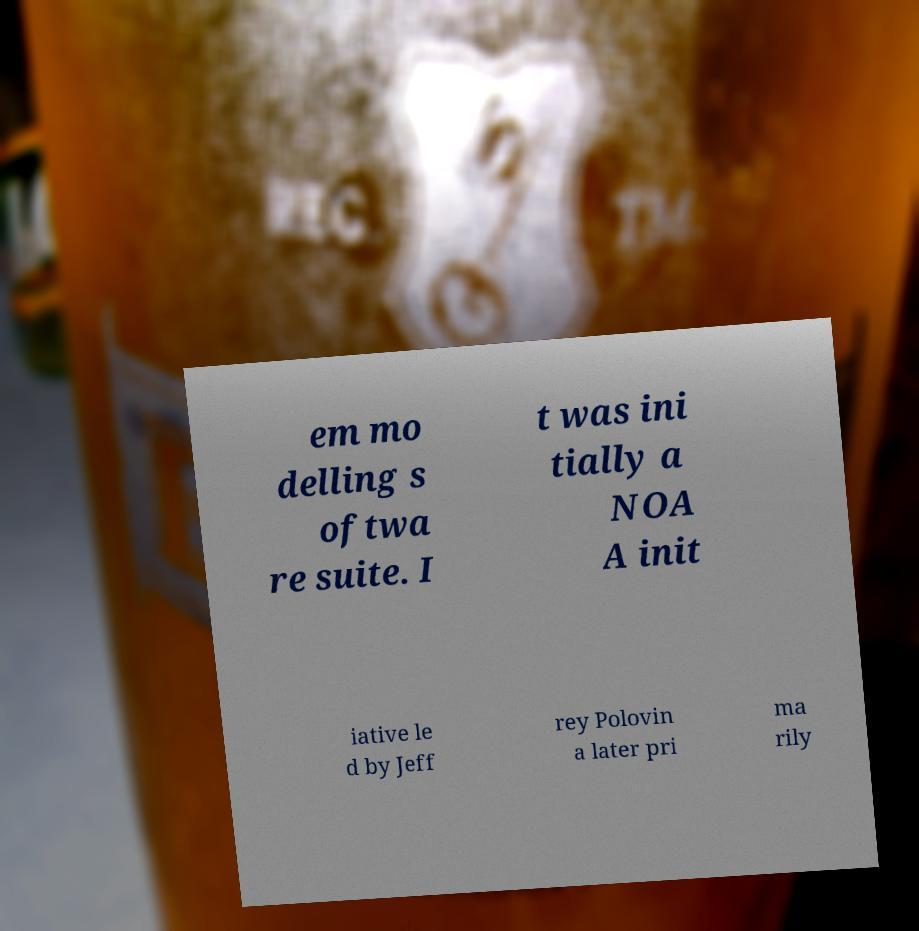For documentation purposes, I need the text within this image transcribed. Could you provide that? em mo delling s oftwa re suite. I t was ini tially a NOA A init iative le d by Jeff rey Polovin a later pri ma rily 